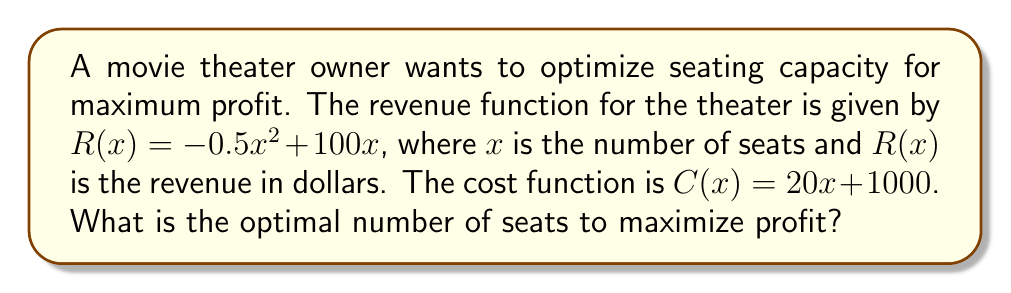Provide a solution to this math problem. 1. Define the profit function $P(x)$:
   $P(x) = R(x) - C(x)$
   $P(x) = (-0.5x^2 + 100x) - (20x + 1000)$
   $P(x) = -0.5x^2 + 80x - 1000$

2. To find the maximum profit, we need to find the vertex of this quadratic function. The x-coordinate of the vertex will give us the optimal number of seats.

3. For a quadratic function in the form $ax^2 + bx + c$, the x-coordinate of the vertex is given by $x = -\frac{b}{2a}$

4. In our case, $a = -0.5$, $b = 80$, and $c = -1000$

5. Calculate the optimal number of seats:
   $x = -\frac{b}{2a} = -\frac{80}{2(-0.5)} = -\frac{80}{-1} = 80$

6. Therefore, the optimal number of seats is 80.
Answer: 80 seats 